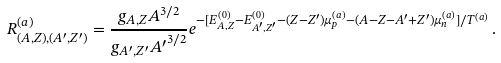<formula> <loc_0><loc_0><loc_500><loc_500>R ^ { ( a ) } _ { ( A , Z ) , ( A ^ { \prime } , Z ^ { \prime } ) } = \frac { g _ { A , Z } A ^ { 3 / 2 } } { g _ { A ^ { \prime } , Z ^ { \prime } } { A ^ { \prime } } ^ { 3 / 2 } } e ^ { - [ E ^ { ( 0 ) } _ { A , Z } - E ^ { ( 0 ) } _ { A ^ { \prime } , Z ^ { \prime } } - ( Z - Z ^ { \prime } ) \mu ^ { ( a ) } _ { p } - ( A - Z - A ^ { \prime } + Z ^ { \prime } ) \mu ^ { ( a ) } _ { n } ] / T ^ { ( a ) } } \, .</formula> 